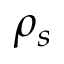<formula> <loc_0><loc_0><loc_500><loc_500>\rho _ { s }</formula> 